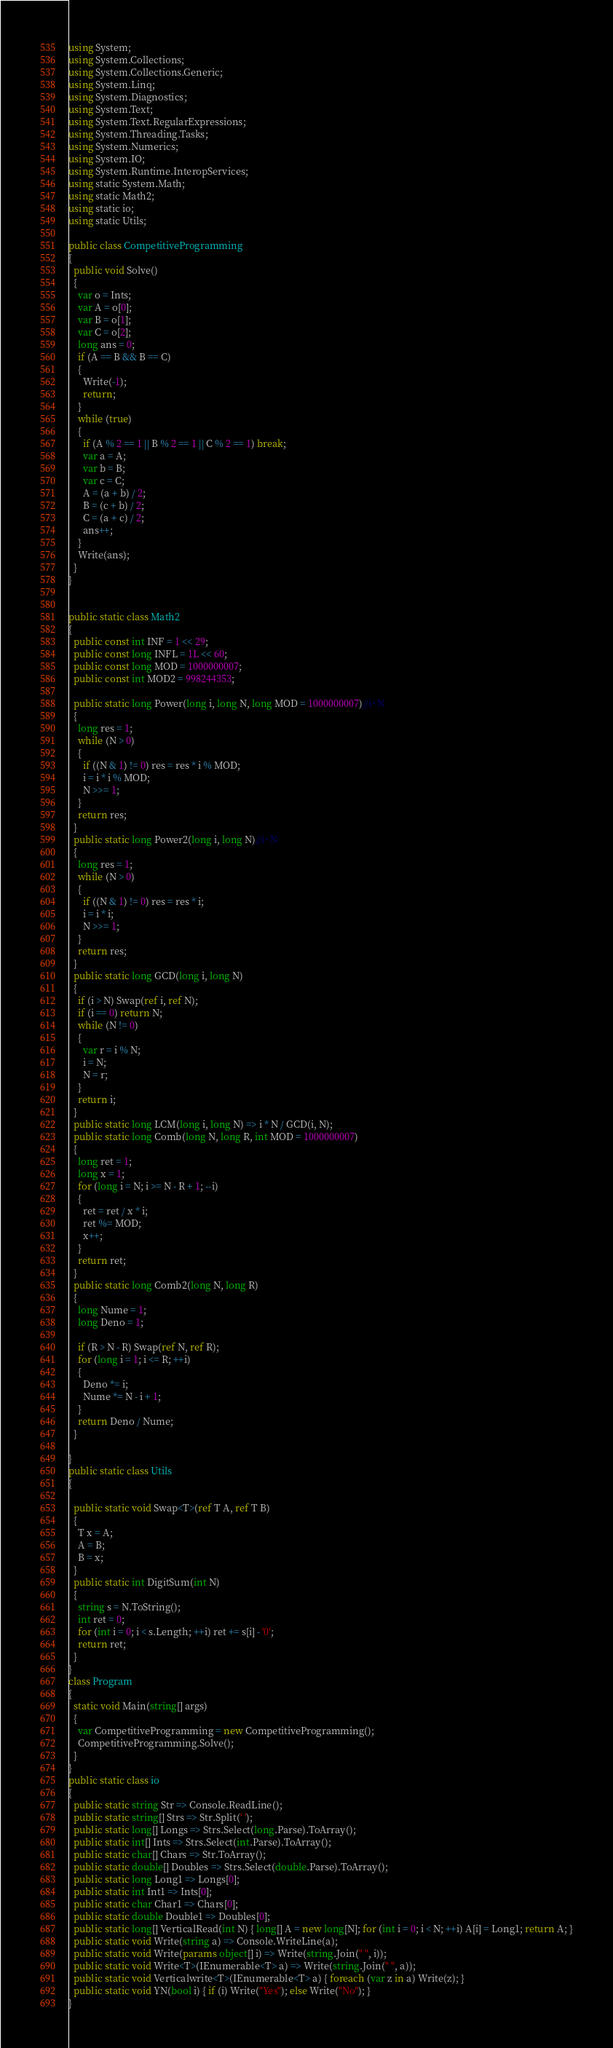<code> <loc_0><loc_0><loc_500><loc_500><_C#_>using System;
using System.Collections;
using System.Collections.Generic;
using System.Linq;
using System.Diagnostics;
using System.Text;
using System.Text.RegularExpressions;
using System.Threading.Tasks;
using System.Numerics;
using System.IO;
using System.Runtime.InteropServices;
using static System.Math;
using static Math2;
using static io;
using static Utils;

public class CompetitiveProgramming
{
  public void Solve()
  {
    var o = Ints;
    var A = o[0];
    var B = o[1];
    var C = o[2];
    long ans = 0;
    if (A == B && B == C)
    {
      Write(-1);
      return;
    }
    while (true)
    {
      if (A % 2 == 1 || B % 2 == 1 || C % 2 == 1) break;
      var a = A;
      var b = B;
      var c = C;
      A = (a + b) / 2;
      B = (c + b) / 2;
      C = (a + c) / 2;
      ans++;
    }
    Write(ans);
  }
}


public static class Math2
{
  public const int INF = 1 << 29;
  public const long INFL = 1L << 60;
  public const long MOD = 1000000007;
  public const int MOD2 = 998244353;

  public static long Power(long i, long N, long MOD = 1000000007)//i^N
  {
    long res = 1;
    while (N > 0)
    {
      if ((N & 1) != 0) res = res * i % MOD;
      i = i * i % MOD;
      N >>= 1;
    }
    return res;
  }
  public static long Power2(long i, long N)//i^N
  {
    long res = 1;
    while (N > 0)
    {
      if ((N & 1) != 0) res = res * i;
      i = i * i;
      N >>= 1;
    }
    return res;
  }
  public static long GCD(long i, long N)
  {
    if (i > N) Swap(ref i, ref N);
    if (i == 0) return N;
    while (N != 0)
    {
      var r = i % N;
      i = N;
      N = r;
    }
    return i;
  }
  public static long LCM(long i, long N) => i * N / GCD(i, N);
  public static long Comb(long N, long R, int MOD = 1000000007)
  {
    long ret = 1;
    long x = 1;
    for (long i = N; i >= N - R + 1; --i)
    {
      ret = ret / x * i;
      ret %= MOD;
      x++;
    }
    return ret;
  }
  public static long Comb2(long N, long R)
  {
    long Nume = 1;
    long Deno = 1;

    if (R > N - R) Swap(ref N, ref R);
    for (long i = 1; i <= R; ++i)
    {
      Deno *= i;
      Nume *= N - i + 1;
    }
    return Deno / Nume;
  }

}
public static class Utils
{

  public static void Swap<T>(ref T A, ref T B)
  {
    T x = A;
    A = B;
    B = x;
  }
  public static int DigitSum(int N)
  {
    string s = N.ToString();
    int ret = 0;
    for (int i = 0; i < s.Length; ++i) ret += s[i] - '0';
    return ret;
  }
}
class Program
{
  static void Main(string[] args)
  {
    var CompetitiveProgramming = new CompetitiveProgramming();
    CompetitiveProgramming.Solve();
  }
}
public static class io
{
  public static string Str => Console.ReadLine();
  public static string[] Strs => Str.Split(' ');
  public static long[] Longs => Strs.Select(long.Parse).ToArray();
  public static int[] Ints => Strs.Select(int.Parse).ToArray();
  public static char[] Chars => Str.ToArray();
  public static double[] Doubles => Strs.Select(double.Parse).ToArray();
  public static long Long1 => Longs[0];
  public static int Int1 => Ints[0];
  public static char Char1 => Chars[0];
  public static double Double1 => Doubles[0];
  public static long[] VerticalRead(int N) { long[] A = new long[N]; for (int i = 0; i < N; ++i) A[i] = Long1; return A; }
  public static void Write(string a) => Console.WriteLine(a);
  public static void Write(params object[] i) => Write(string.Join(" ", i));
  public static void Write<T>(IEnumerable<T> a) => Write(string.Join(" ", a));
  public static void Verticalwrite<T>(IEnumerable<T> a) { foreach (var z in a) Write(z); }
  public static void YN(bool i) { if (i) Write("Yes"); else Write("No"); }
}
</code> 